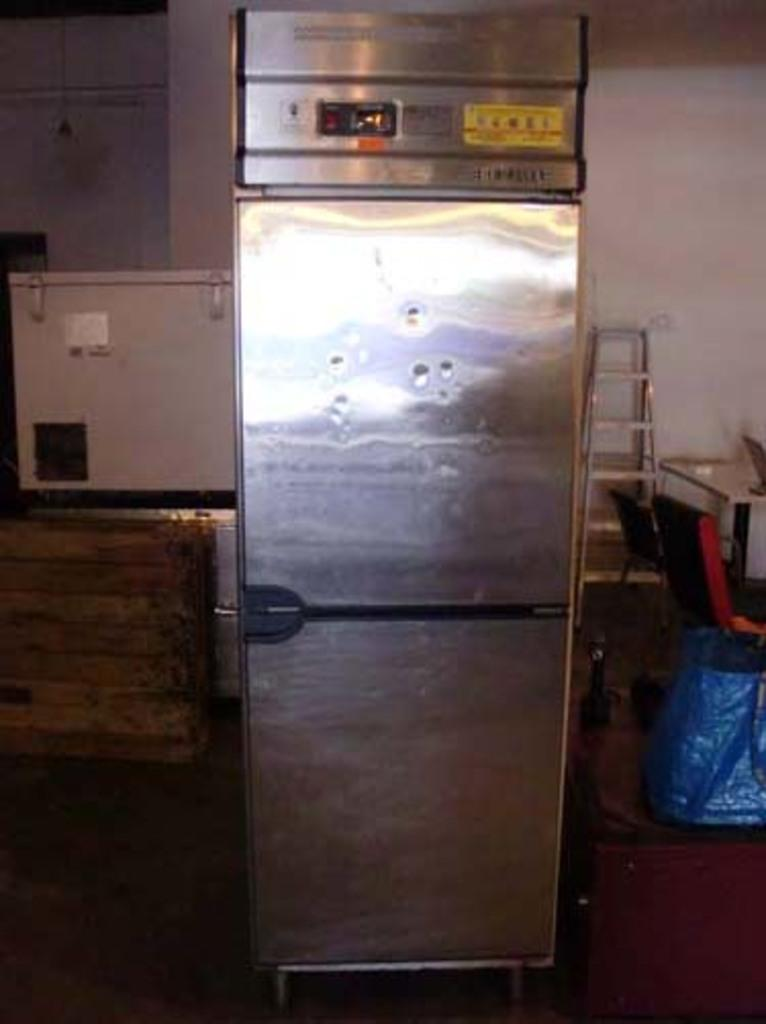<image>
Create a compact narrative representing the image presented. Silver refrigerator has a yellow sticker which has uncomprehensible letters on it. 